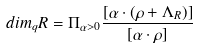Convert formula to latex. <formula><loc_0><loc_0><loc_500><loc_500>d i m _ { q } R = \Pi _ { \alpha > 0 } \frac { [ \alpha \cdot ( \rho + \Lambda _ { R } ) ] } { [ \alpha \cdot \rho ] }</formula> 